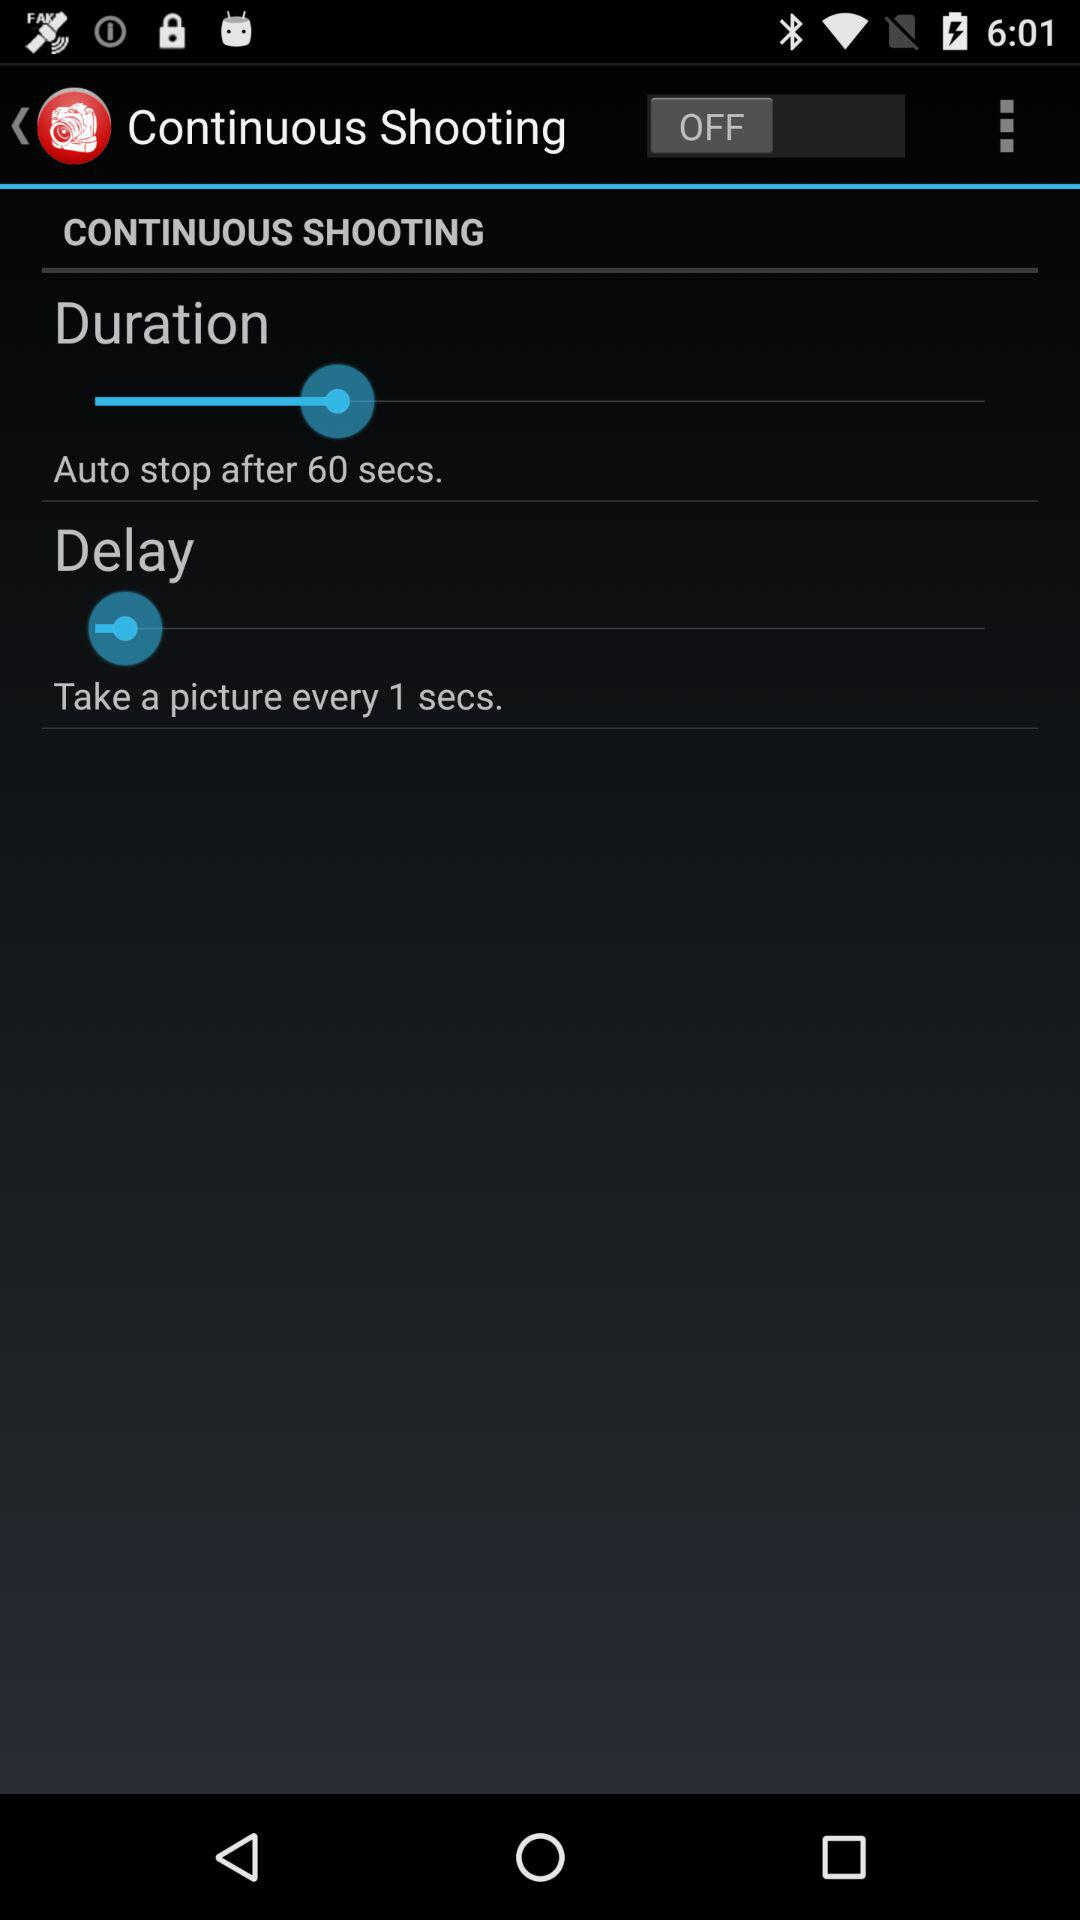When does the shooting automatically stop? The shooting automatically stops after 60 seconds. 